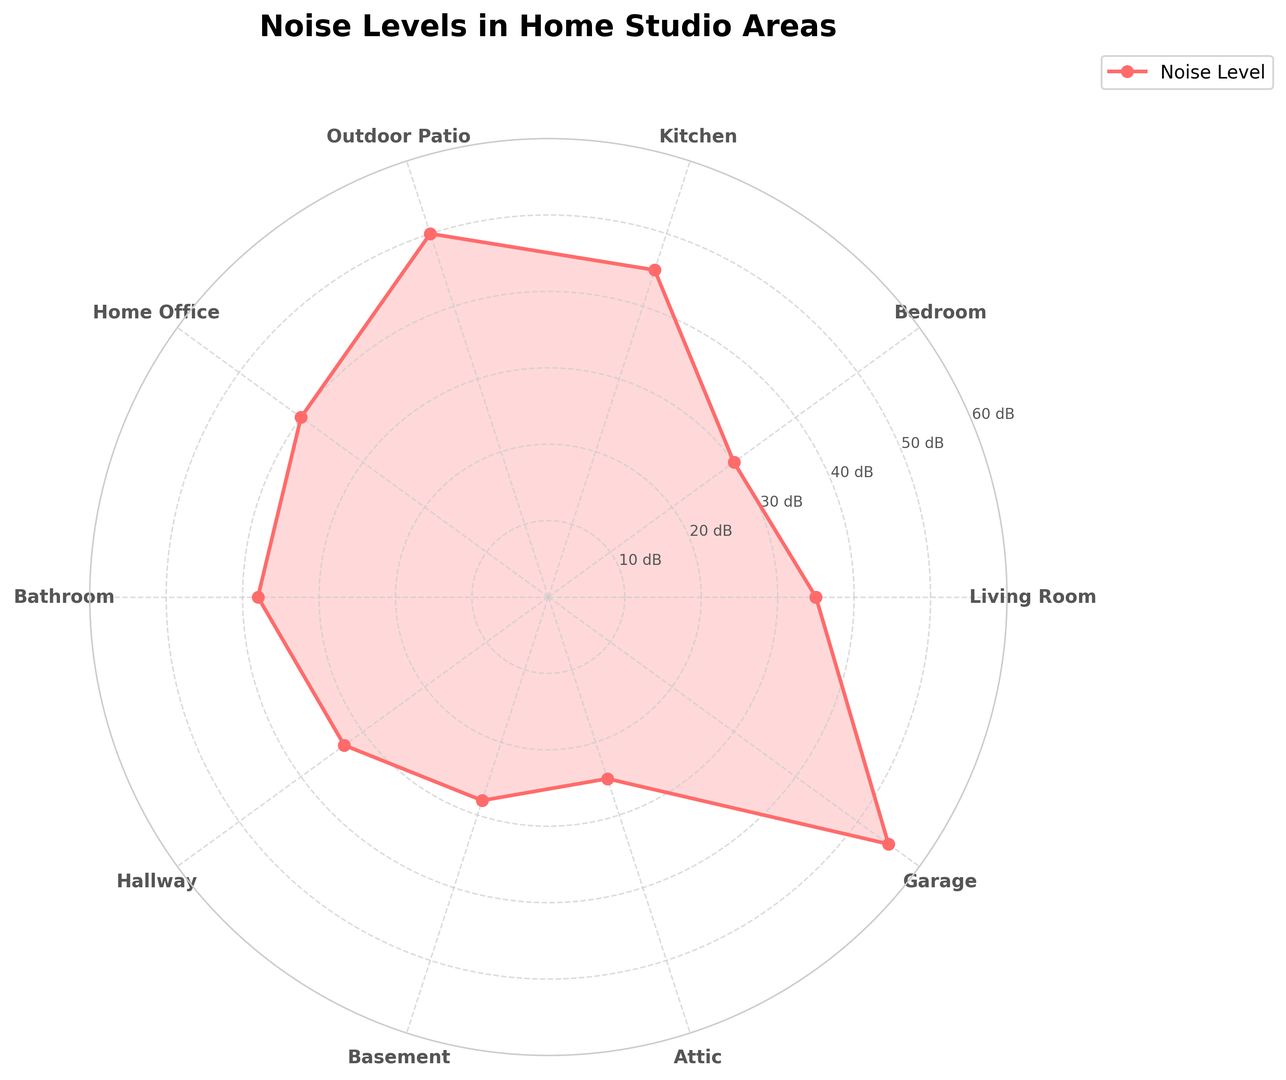1. Which area has the highest noise level? The highest point on the radar chart represents the Garage, which reaches 55 dB.
Answer: Garage 2. Which area has the lowest noise level? The lowest point on the radar chart corresponds to the Attic, which is 25 dB.
Answer: Attic 3. How much higher is the noise level in the Kitchen compared to the Bedroom? The noise level in the Kitchen is 45 dB, and in the Bedroom, it is 30 dB. The difference is 45 - 30 = 15 dB.
Answer: 15 dB 4. What is the average noise level across all areas? Summing all noise levels: 35 + 30 + 45 + 50 + 40 + 38 + 33 + 28 + 25 + 55 = 379. There are 10 areas, so the average is 379 / 10 = 37.9 dB.
Answer: 37.9 dB 5. Which areas have noise levels greater than 40 dB? Looking at the radar chart, the Kitchen (45 dB), Outdoor Patio (50 dB), and Garage (55 dB) are the areas with noise levels greater than 40 dB.
Answer: Kitchen, Outdoor Patio, Garage 6. What is the difference in noise levels between the Home Office and the Living Room? The noise level in the Home Office is 40 dB, and in the Living Room, it is 35 dB. The difference is 40 - 35 = 5 dB.
Answer: 5 dB 7. How much quieter is the Basement compared to the Bathroom? The noise level in the Basement is 28 dB, and in the Bathroom, it is 38 dB. The difference is 38 - 28 = 10 dB.
Answer: 10 dB 8. Which area has a noise level closest to 35 dB? The radar chart shows the Living Room has a noise level of 35 dB, which matches exactly.
Answer: Living Room 9. Identify the range of noise levels in the data. The lowest noise level is 25 dB (Attic) and the highest is 55 dB (Garage), giving a range of 55 - 25 = 30 dB.
Answer: 30 dB 10. What is the second highest noise level recorded on the chart? The highest noise level is in the Garage (55 dB). The second highest is the Outdoor Patio at 50 dB.
Answer: Outdoor Patio 